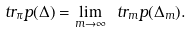<formula> <loc_0><loc_0><loc_500><loc_500>\ t r _ { \pi } p ( \Delta ) = \lim _ { m \to \infty } \ t r _ { m } p ( \Delta _ { m } ) .</formula> 